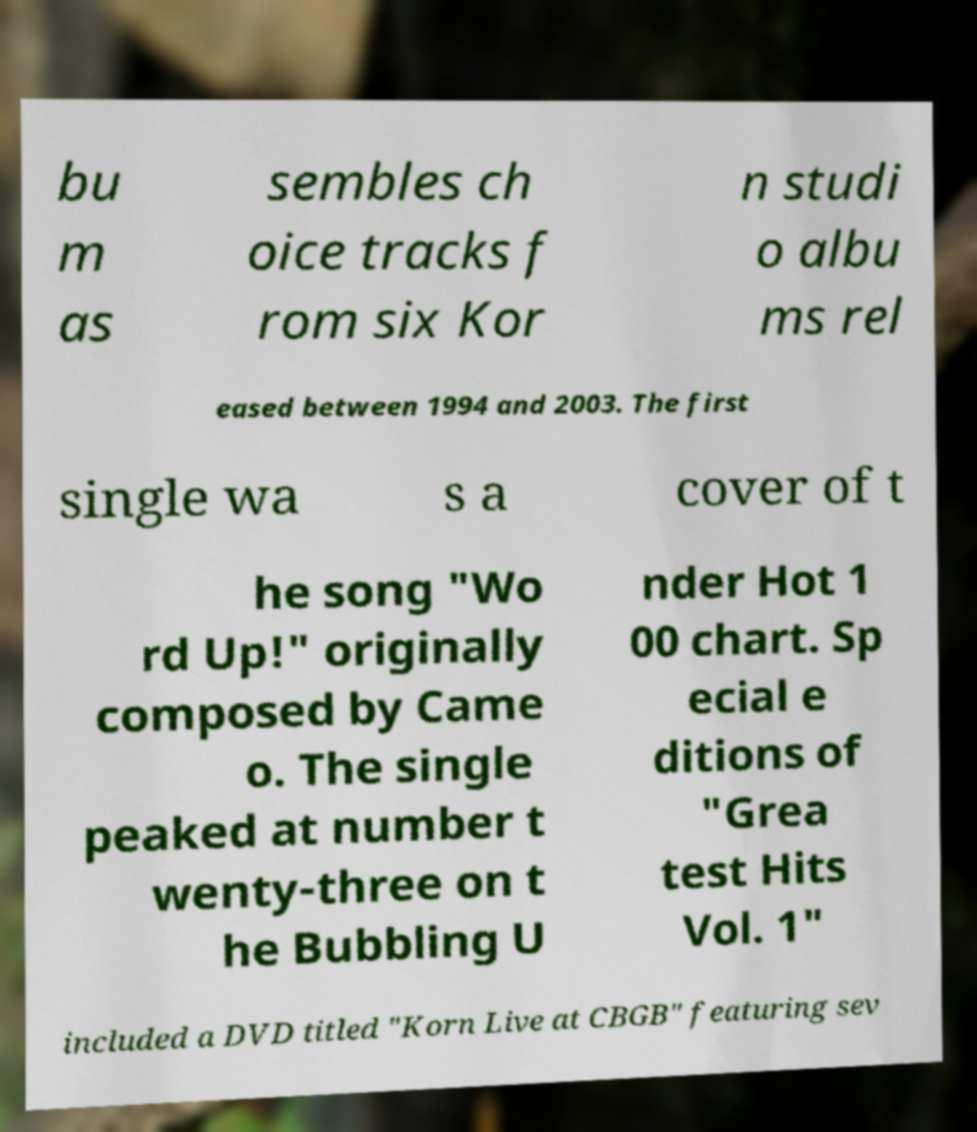I need the written content from this picture converted into text. Can you do that? bu m as sembles ch oice tracks f rom six Kor n studi o albu ms rel eased between 1994 and 2003. The first single wa s a cover of t he song "Wo rd Up!" originally composed by Came o. The single peaked at number t wenty-three on t he Bubbling U nder Hot 1 00 chart. Sp ecial e ditions of "Grea test Hits Vol. 1" included a DVD titled "Korn Live at CBGB" featuring sev 